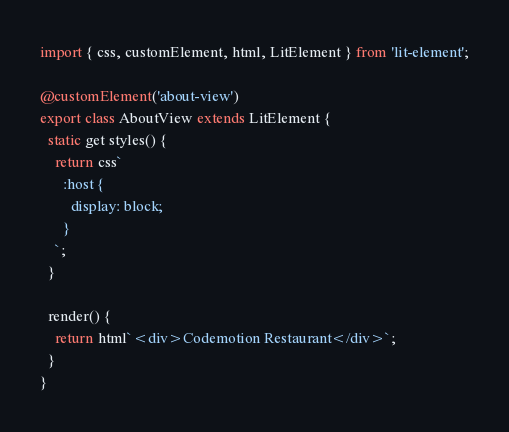Convert code to text. <code><loc_0><loc_0><loc_500><loc_500><_TypeScript_>import { css, customElement, html, LitElement } from 'lit-element';

@customElement('about-view')
export class AboutView extends LitElement {
  static get styles() {
    return css`
      :host {
        display: block;
      }
    `;
  }

  render() {
    return html`<div>Codemotion Restaurant</div>`;
  }
}
</code> 